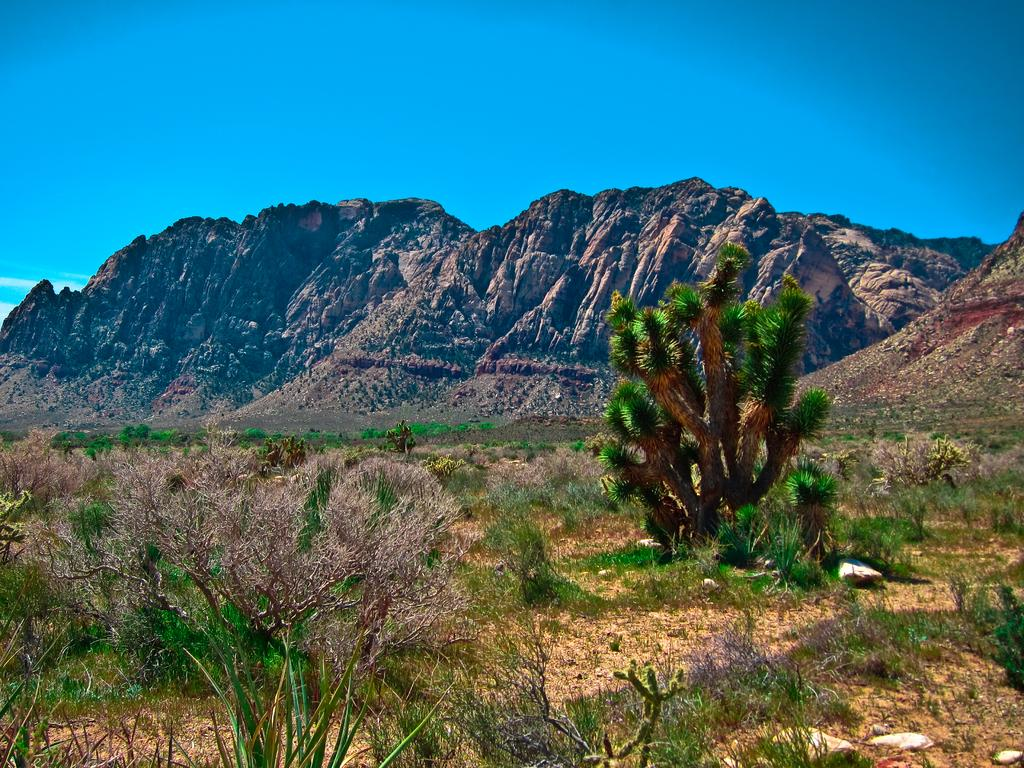What type of vegetation or plants can be seen at the bottom of the image? There is greenery at the bottom side of the image. What geographical feature is located at the center of the image? There are mountains at the center of the image. What type of grain is being harvested in the image? There is no grain present in the image; it features greenery and mountains. What type of silk is draped over the mountains in the image? There is no silk present in the image; it features greenery and mountains. 